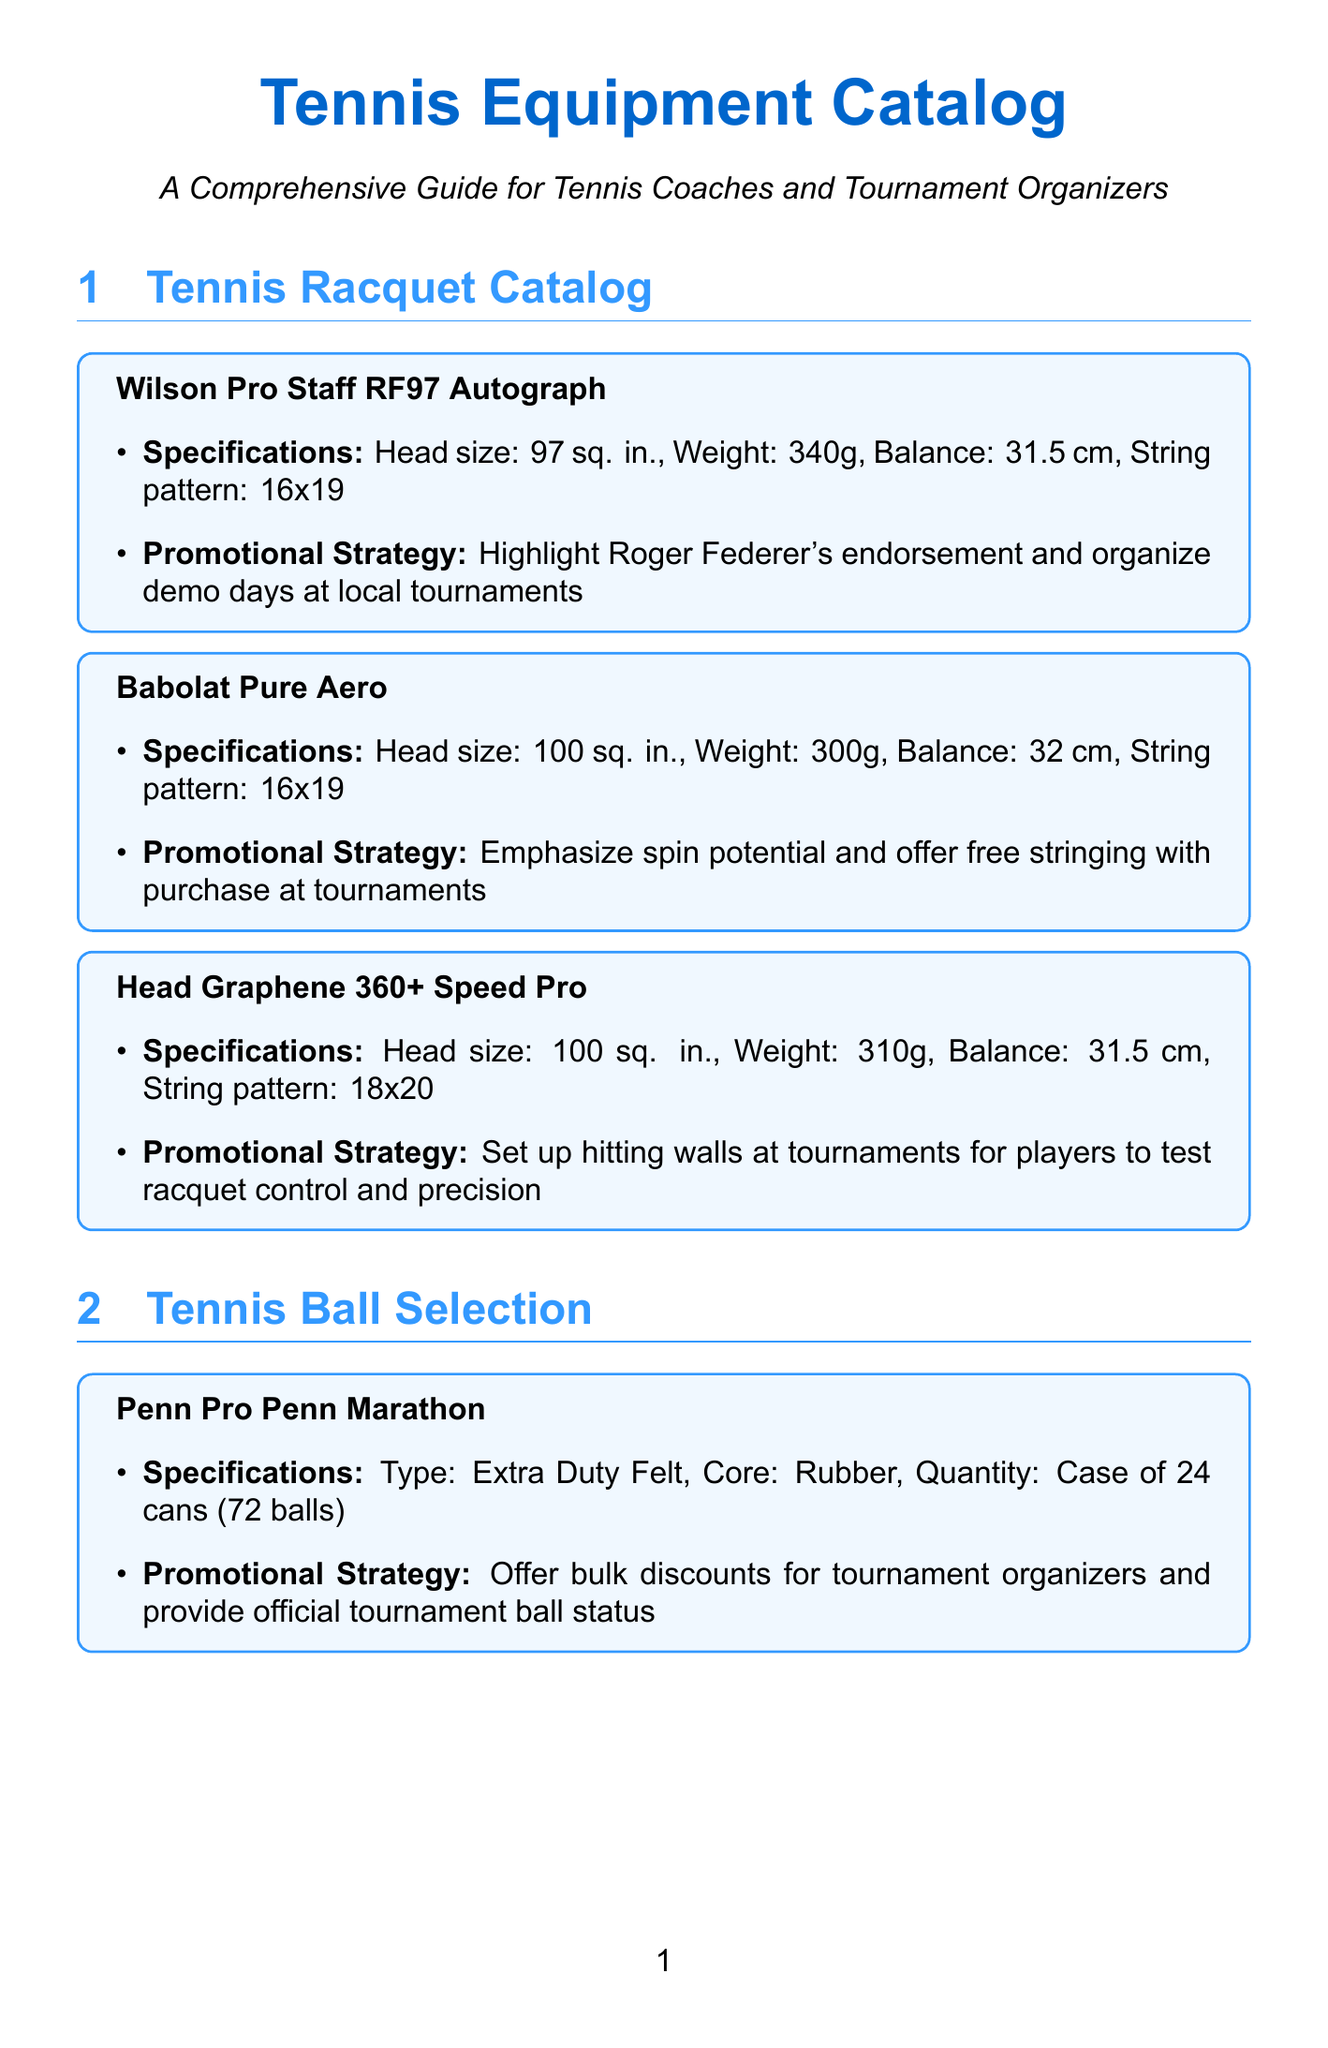What is the head size of the Babolat Pure Aero? The head size for the Babolat Pure Aero is specified in the document.
Answer: 100 sq. in Who endorses the Wilson Pro Staff RF97 Autograph? The document lists the promotional strategy for the Wilson racquet, which includes an endorsement by Roger Federer.
Answer: Roger Federer What type of material is the Nike Court Dri-FIT Victory Top made from? The specifications for the Nike Court Dri-FIT Victory Top mention the material used.
Answer: 100% recycled polyester What is the weight of the Head Graphene 360+ Speed Pro racquet? The weight of the Head Graphene 360+ Speed Pro racquet is found in its specifications.
Answer: 310g Which brand offers a trial session for their Elite Liberty Tennis Ball Machine? The document specifies the promotional strategies of equipment, including trial sessions for the ball machine.
Answer: LOBSTER How many cans are in a case of Wilson US Open Extra Duty balls? The quantity of balls in a case for the Wilson US Open Extra Duty is clearly stated in the document.
Answer: 72 balls What is the promotional strategy for Gamma Pro Grip Overgrip? The promotional strategy for the Gamma Pro Grip Overgrip is detailed in the document.
Answer: Include free overgrip with racquet purchase What type of cushioning does the ASICS Gel-Resolution 8 employ? The specifications for the ASICS Gel-Resolution 8 mention the cushioning method used.
Answer: Gel and FlyteFoam How is the tennis ball trainer demonstrated? The document explains how the tennis trainer's usage is promoted through demonstrations.
Answer: During coaching sessions 